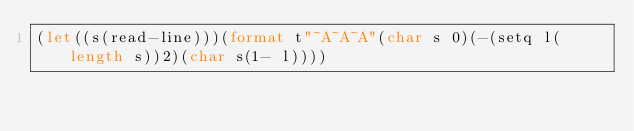<code> <loc_0><loc_0><loc_500><loc_500><_Lisp_>(let((s(read-line)))(format t"~A~A~A"(char s 0)(-(setq l(length s))2)(char s(1- l))))</code> 